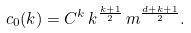<formula> <loc_0><loc_0><loc_500><loc_500>c _ { 0 } ( k ) = C ^ { k } \, k ^ { \frac { k + 1 } { 2 } } \, m ^ { \frac { d + k + 1 } { 2 } } .</formula> 